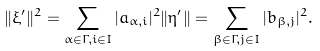Convert formula to latex. <formula><loc_0><loc_0><loc_500><loc_500>\| \xi ^ { \prime } \| ^ { 2 } = \sum _ { \alpha \in \Gamma , i \in I } | a _ { \alpha , i } | ^ { 2 } \| \eta ^ { \prime } \| = \sum _ { \beta \in \Gamma , j \in I } | b _ { \beta , j } | ^ { 2 } .</formula> 